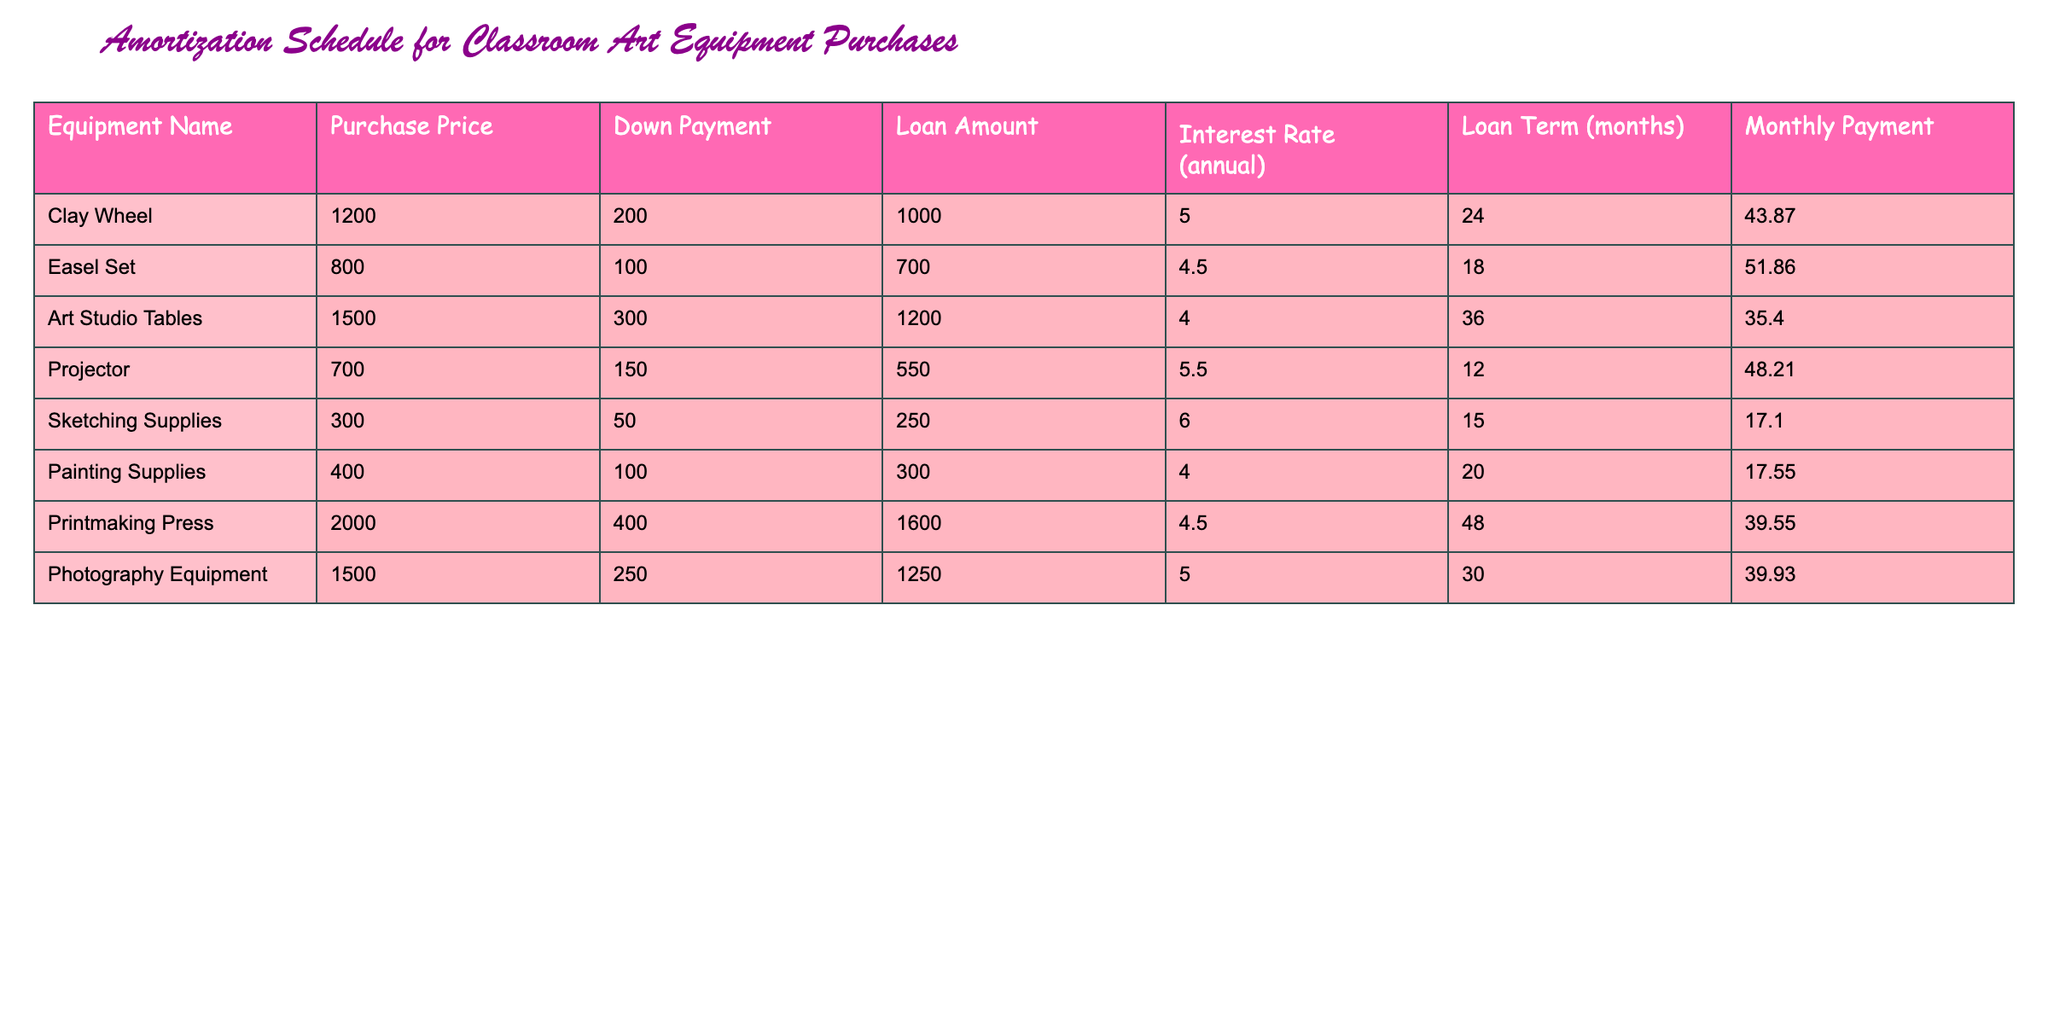What is the purchase price of the Easel Set? The purchase price of the Easel Set can be found in the corresponding row under the "Purchase Price" column. It is listed as 800.
Answer: 800 What is the total loan amount for the Printmaking Press and the Photography Equipment? To find the total loan amount, we need to add the loan amounts for both items: Printmaking Press is 1600 and Photography Equipment is 1250. The sum is 1600 + 1250 = 2850.
Answer: 2850 Does the Clay Wheel have a higher monthly payment than the Art Studio Tables? The monthly payment for the Clay Wheel is 43.87, and for the Art Studio Tables, it is 35.40. Since 43.87 is greater than 35.40, the statement is true.
Answer: Yes What is the average loan amount for all items listed in the table? First, we calculate the loan amounts for each item: 1000, 700, 1200, 550, 250, 300, 1600, and 1250. The sum of these amounts is 1000 + 700 + 1200 + 550 + 250 + 300 + 1600 + 1250 = 4850. There are 8 items, so the average is 4850 / 8 = 606.25.
Answer: 606.25 What is the difference between the purchase price of the most expensive equipment and the cheapest equipment? The most expensive piece of equipment is the Printmaking Press with a purchase price of 2000, and the cheapest is the Sketching Supplies at 300. The difference is 2000 - 300 = 1700.
Answer: 1700 Does the Art Studio Tables have an interest rate higher than 4%? The interest rate for Art Studio Tables is 4.0, which is equal to 4%, hence it is not higher.
Answer: No If I were to add the down payments for all the equipment, what would be the total? We need to sum the down payments: 200 + 100 + 300 + 150 + 50 + 100 + 400 + 250. The total is 200 + 100 + 300 + 150 + 50 + 100 + 400 + 250 = 1550.
Answer: 1550 